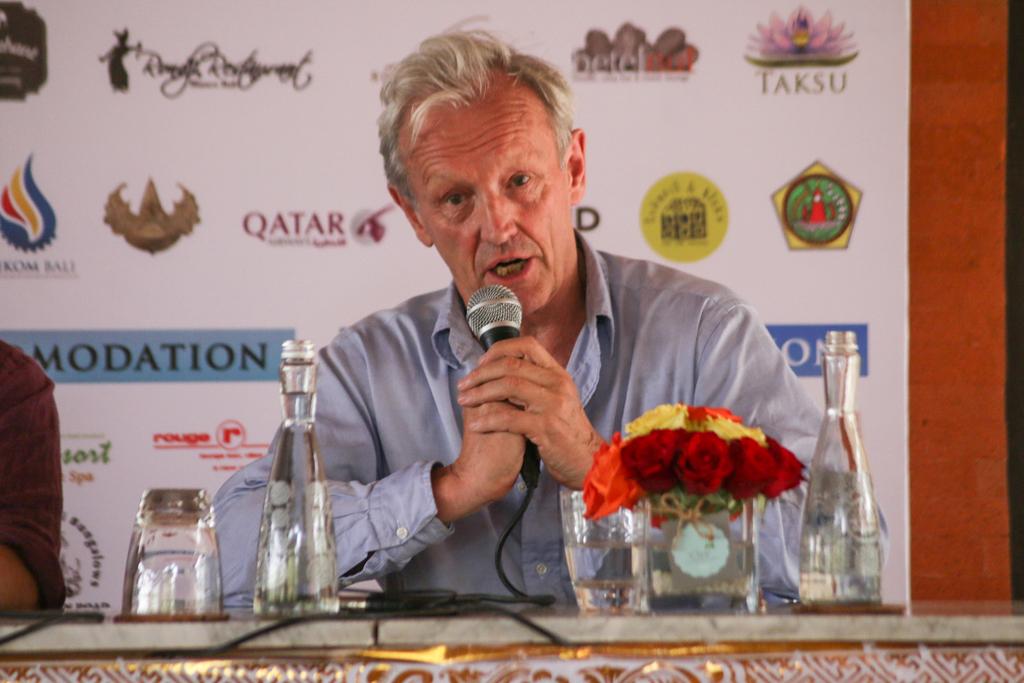What airline sponsors this event?
Make the answer very short. Qatar. What is the name printed under the pink logo?
Your response must be concise. Taksu. 